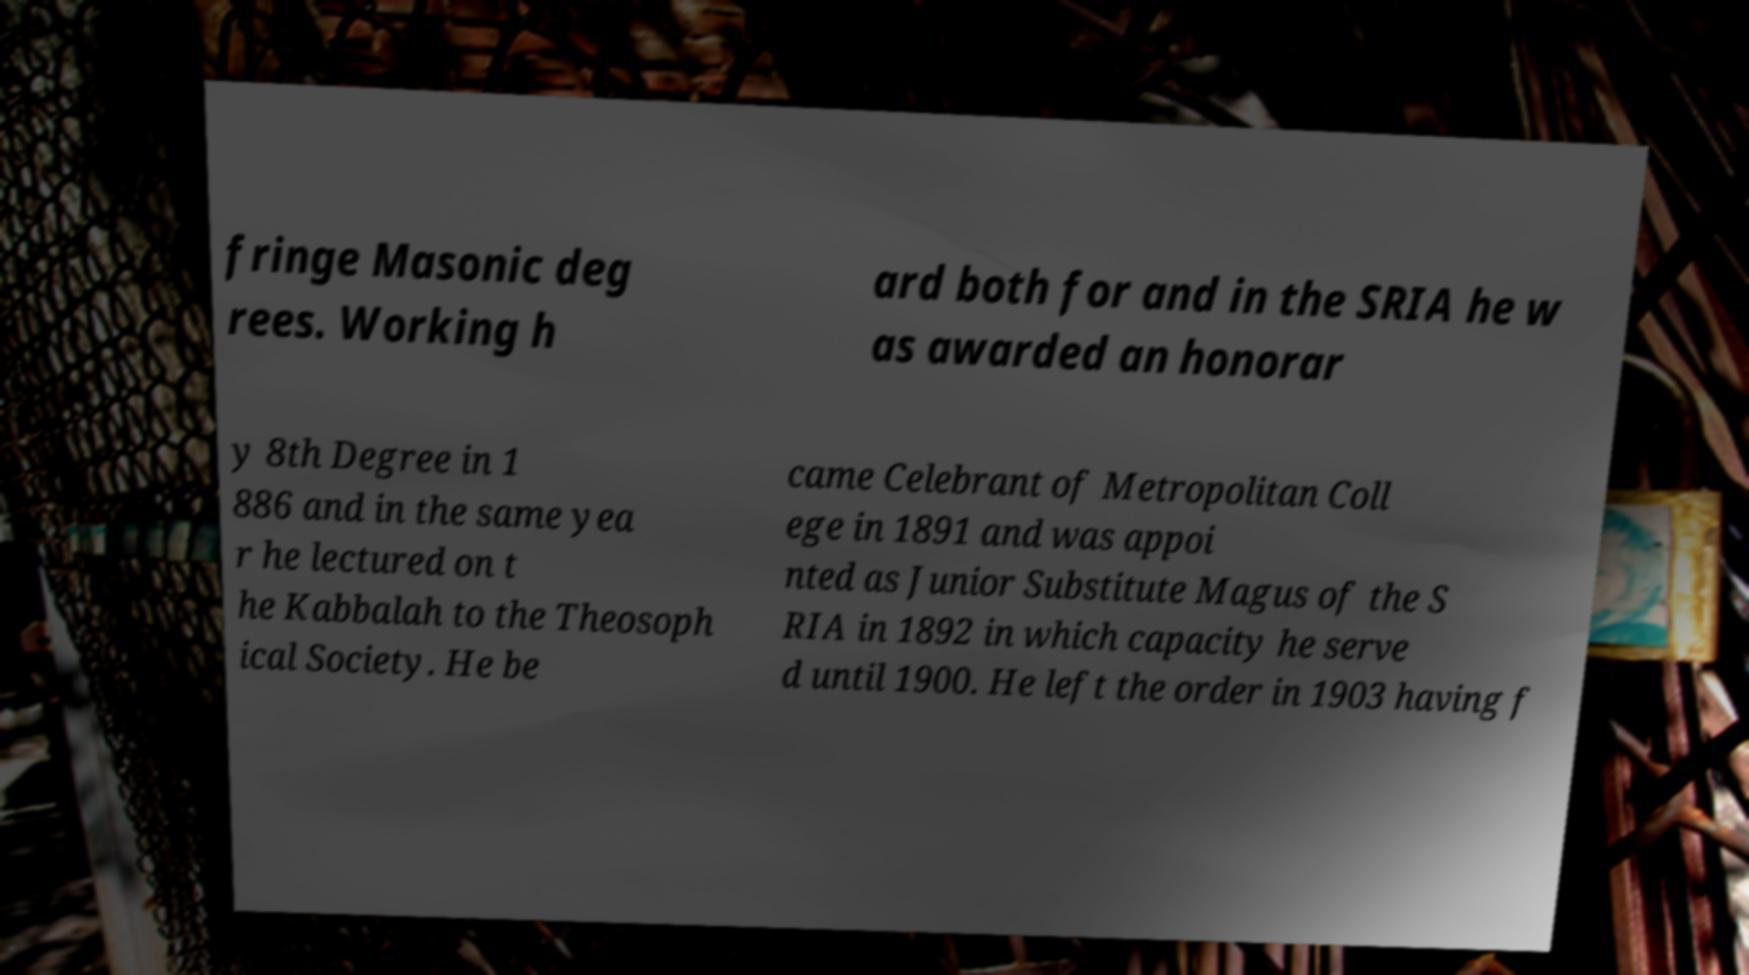Please identify and transcribe the text found in this image. fringe Masonic deg rees. Working h ard both for and in the SRIA he w as awarded an honorar y 8th Degree in 1 886 and in the same yea r he lectured on t he Kabbalah to the Theosoph ical Society. He be came Celebrant of Metropolitan Coll ege in 1891 and was appoi nted as Junior Substitute Magus of the S RIA in 1892 in which capacity he serve d until 1900. He left the order in 1903 having f 